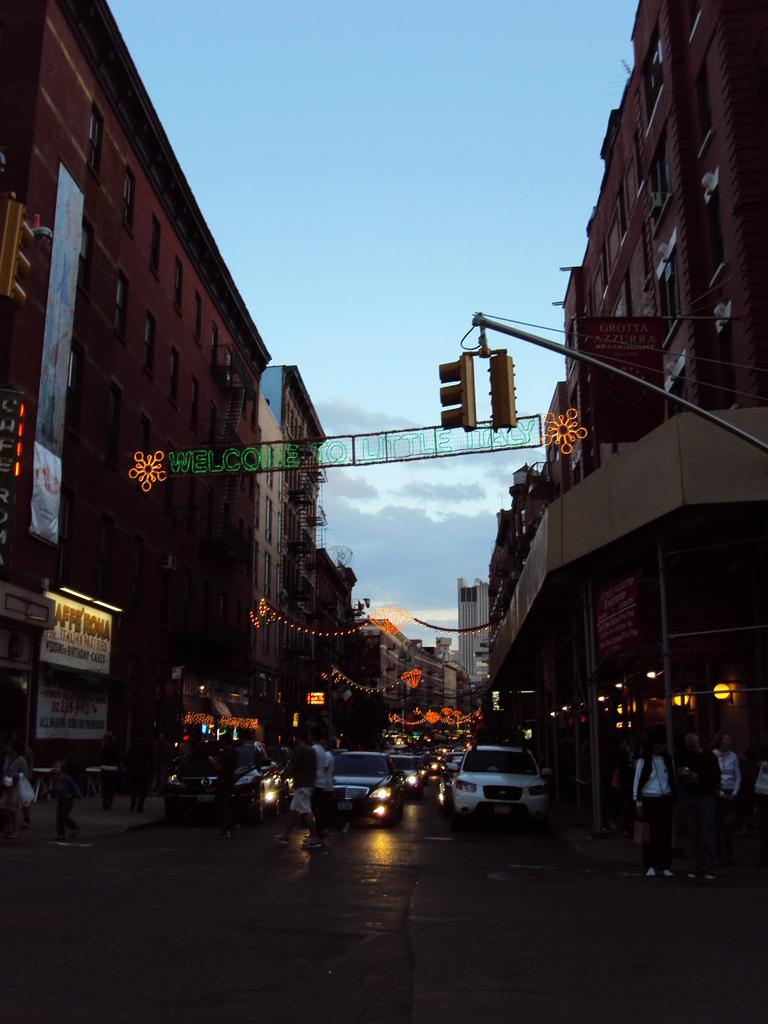What can be seen on the road in the image? There are vehicles on the road in the image. Who or what can be seen in the image besides the vehicles? There are people visible in the image. What is present on both sides of the road in the image? There are buildings on the left and right sides of the image. What is visible in the sky in the background of the image? There are clouds in the sky in the background of the image. Reasoning: Let' Let's think step by step in order to produce the conversation. We start by identifying the main subjects and objects in the image based on the provided facts. We then formulate questions that focus on the location and characteristics of these subjects and objects, ensuring that each question can be answered definitively with the information given. We avoid yes/no questions and ensure that the language is simple and clear. Absurd Question/Answer: What type of button can be seen being pressed by the mother in the image? There is no mother or button present in the image. What effect does the button have on the people in the image? There is no button or effect on the people in the image, as there is no button or mother present. 